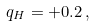Convert formula to latex. <formula><loc_0><loc_0><loc_500><loc_500>q _ { H } = + 0 . 2 \, ,</formula> 